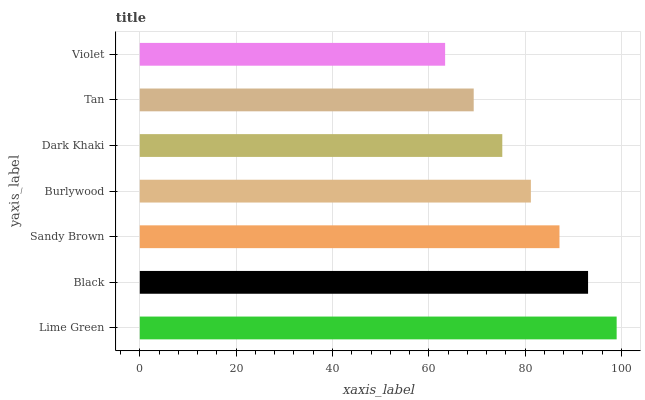Is Violet the minimum?
Answer yes or no. Yes. Is Lime Green the maximum?
Answer yes or no. Yes. Is Black the minimum?
Answer yes or no. No. Is Black the maximum?
Answer yes or no. No. Is Lime Green greater than Black?
Answer yes or no. Yes. Is Black less than Lime Green?
Answer yes or no. Yes. Is Black greater than Lime Green?
Answer yes or no. No. Is Lime Green less than Black?
Answer yes or no. No. Is Burlywood the high median?
Answer yes or no. Yes. Is Burlywood the low median?
Answer yes or no. Yes. Is Violet the high median?
Answer yes or no. No. Is Tan the low median?
Answer yes or no. No. 